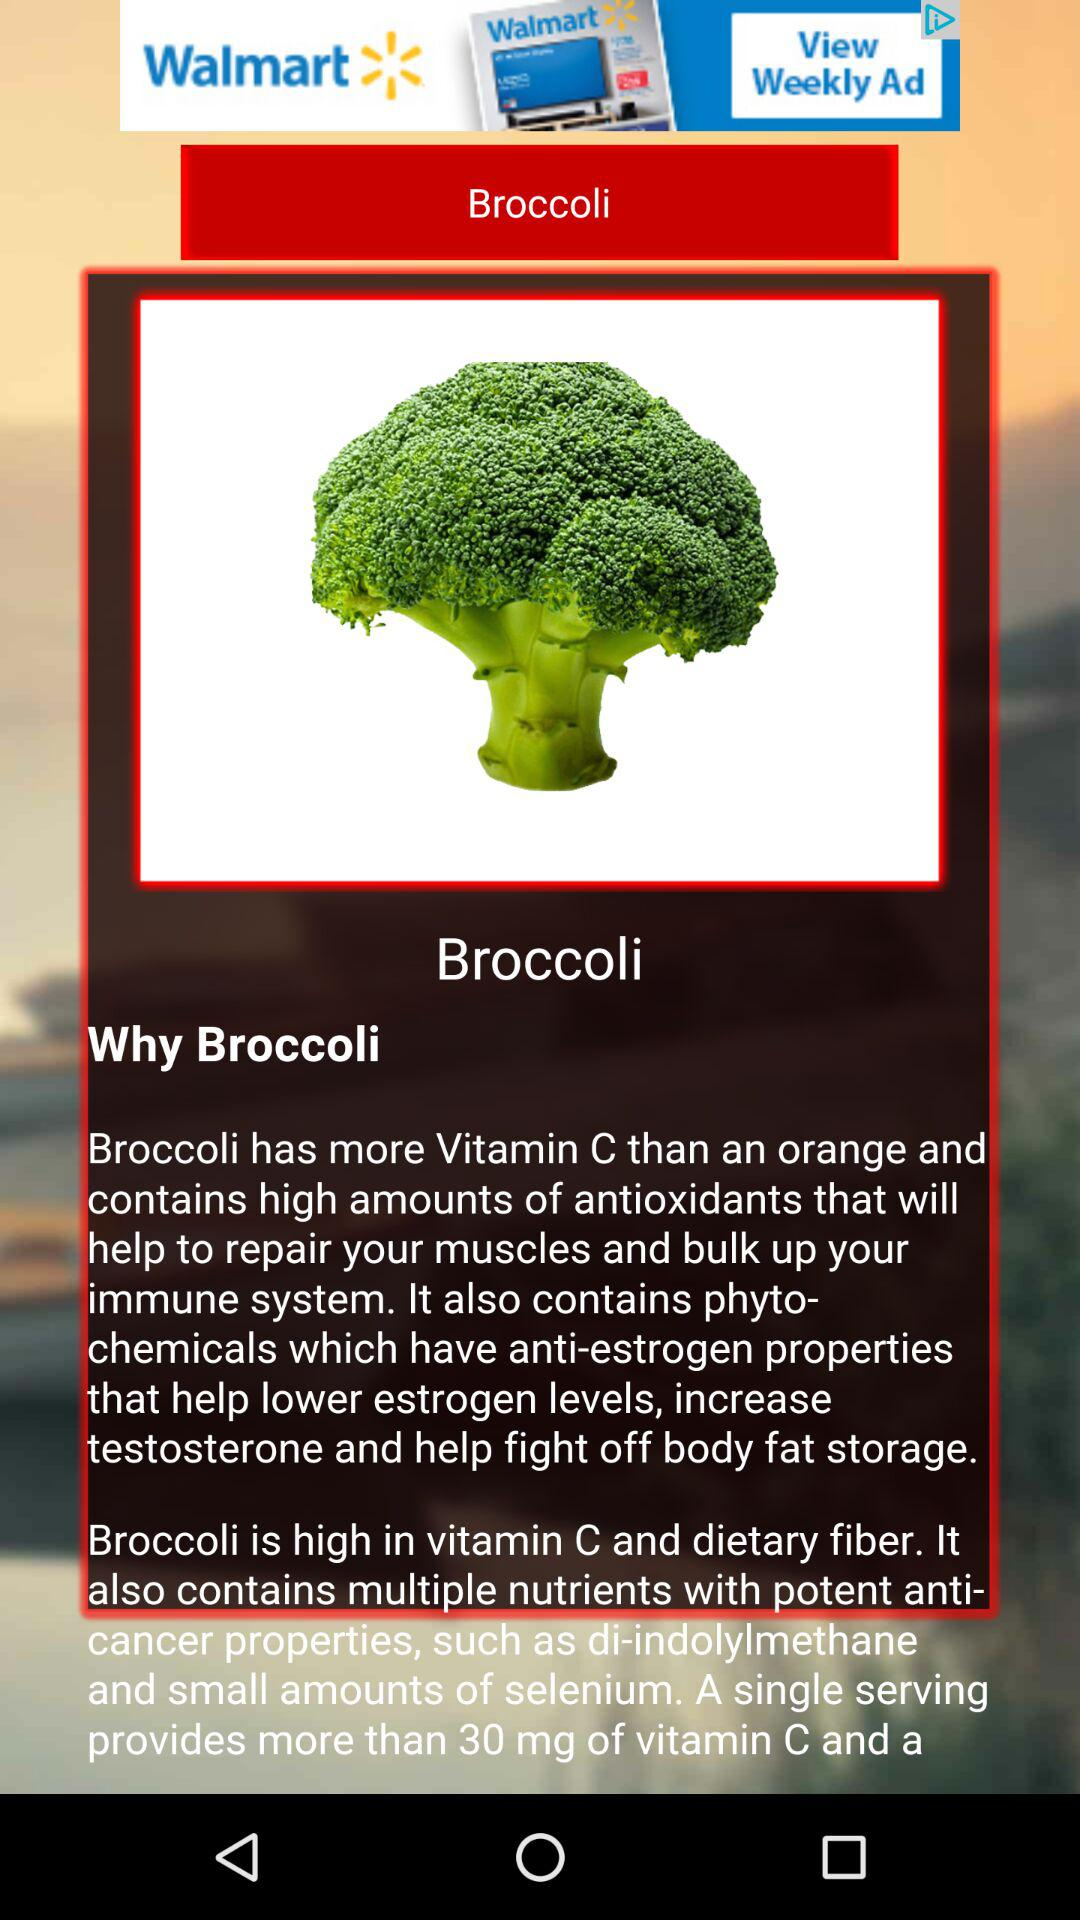What is the name of the vegetable? The name of the vegetable is broccoli. 